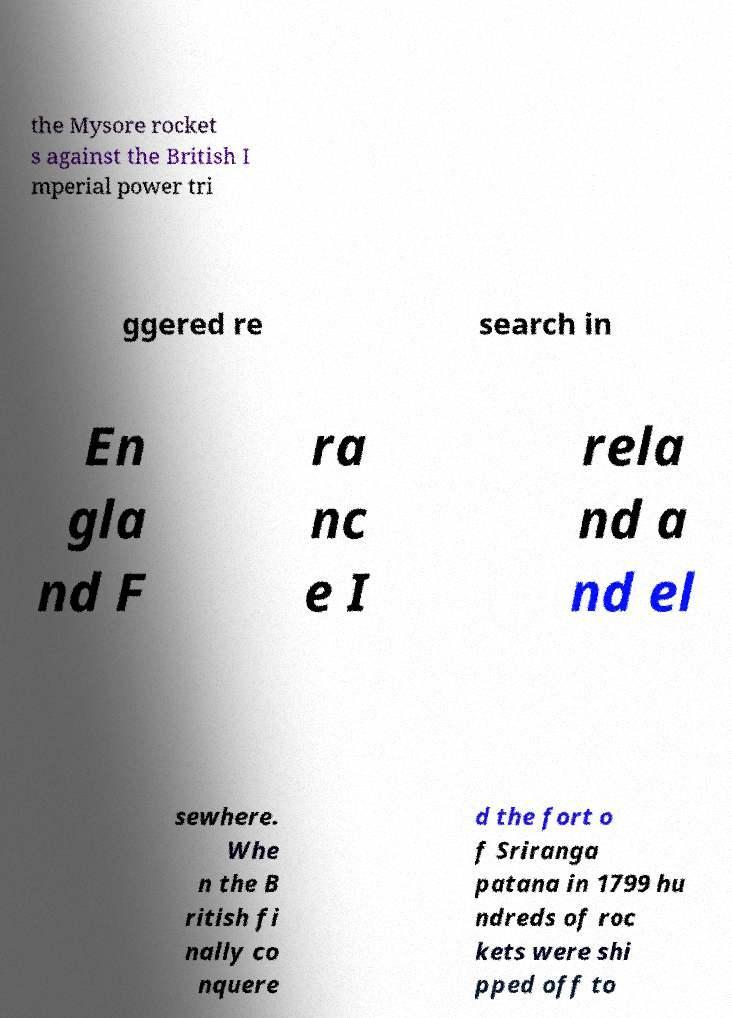There's text embedded in this image that I need extracted. Can you transcribe it verbatim? the Mysore rocket s against the British I mperial power tri ggered re search in En gla nd F ra nc e I rela nd a nd el sewhere. Whe n the B ritish fi nally co nquere d the fort o f Sriranga patana in 1799 hu ndreds of roc kets were shi pped off to 